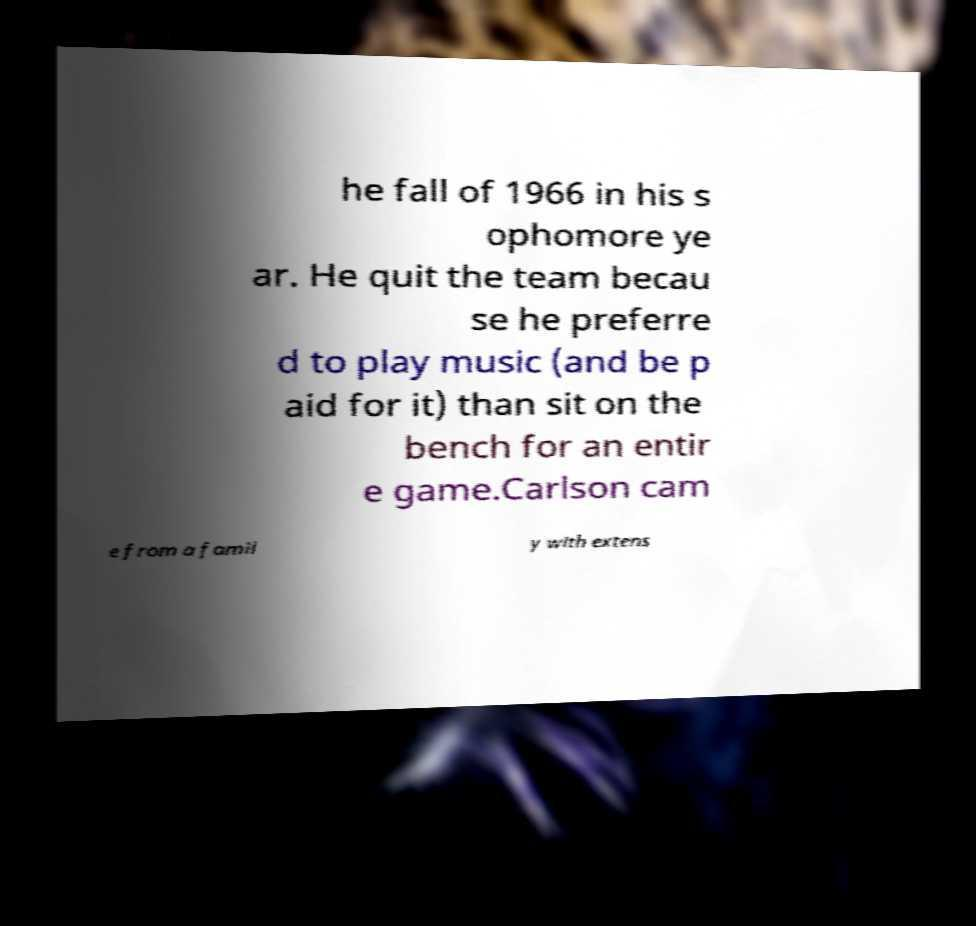What messages or text are displayed in this image? I need them in a readable, typed format. he fall of 1966 in his s ophomore ye ar. He quit the team becau se he preferre d to play music (and be p aid for it) than sit on the bench for an entir e game.Carlson cam e from a famil y with extens 